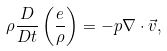Convert formula to latex. <formula><loc_0><loc_0><loc_500><loc_500>\rho \frac { D } { D t } \left ( \frac { e } { \rho } \right ) = - p \nabla \cdot \vec { v } ,</formula> 